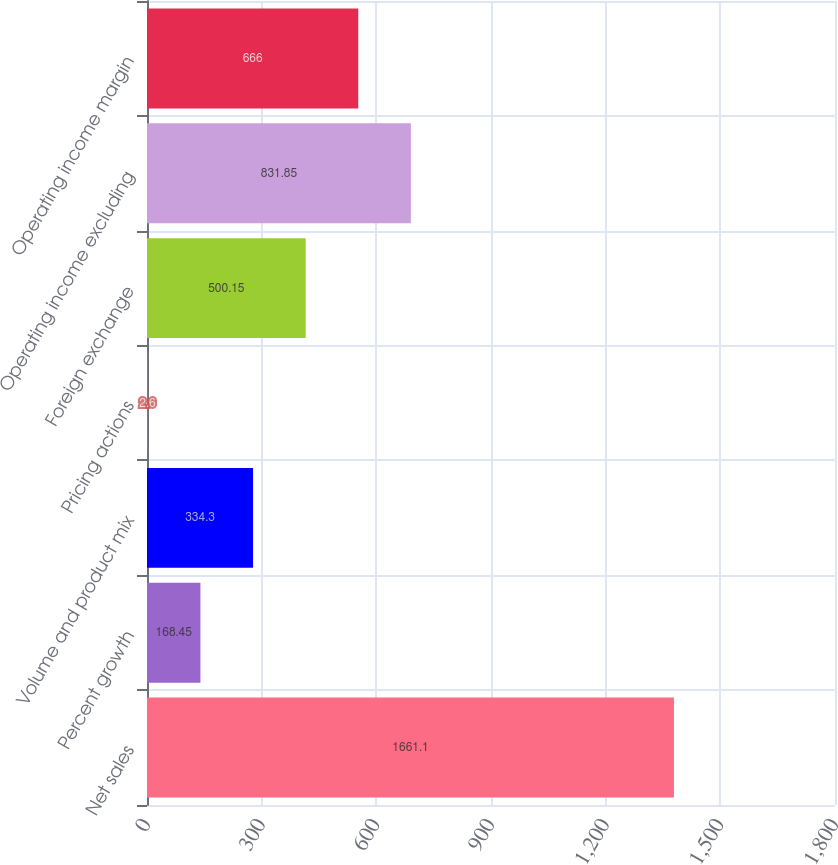Convert chart to OTSL. <chart><loc_0><loc_0><loc_500><loc_500><bar_chart><fcel>Net sales<fcel>Percent growth<fcel>Volume and product mix<fcel>Pricing actions<fcel>Foreign exchange<fcel>Operating income excluding<fcel>Operating income margin<nl><fcel>1661.1<fcel>168.45<fcel>334.3<fcel>2.6<fcel>500.15<fcel>831.85<fcel>666<nl></chart> 